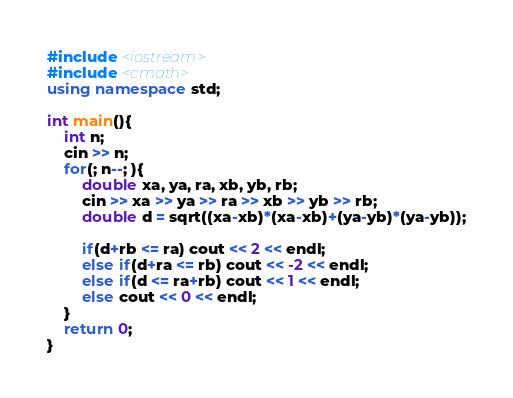<code> <loc_0><loc_0><loc_500><loc_500><_C++_>#include <iostream>
#include <cmath>
using namespace std;

int main(){
	int n;
	cin >> n;
	for(; n--; ){
		double xa, ya, ra, xb, yb, rb;
		cin >> xa >> ya >> ra >> xb >> yb >> rb;
		double d = sqrt((xa-xb)*(xa-xb)+(ya-yb)*(ya-yb));

		if(d+rb <= ra) cout << 2 << endl;
		else if(d+ra <= rb) cout << -2 << endl;
		else if(d <= ra+rb) cout << 1 << endl;
		else cout << 0 << endl;
	}
	return 0;
}</code> 